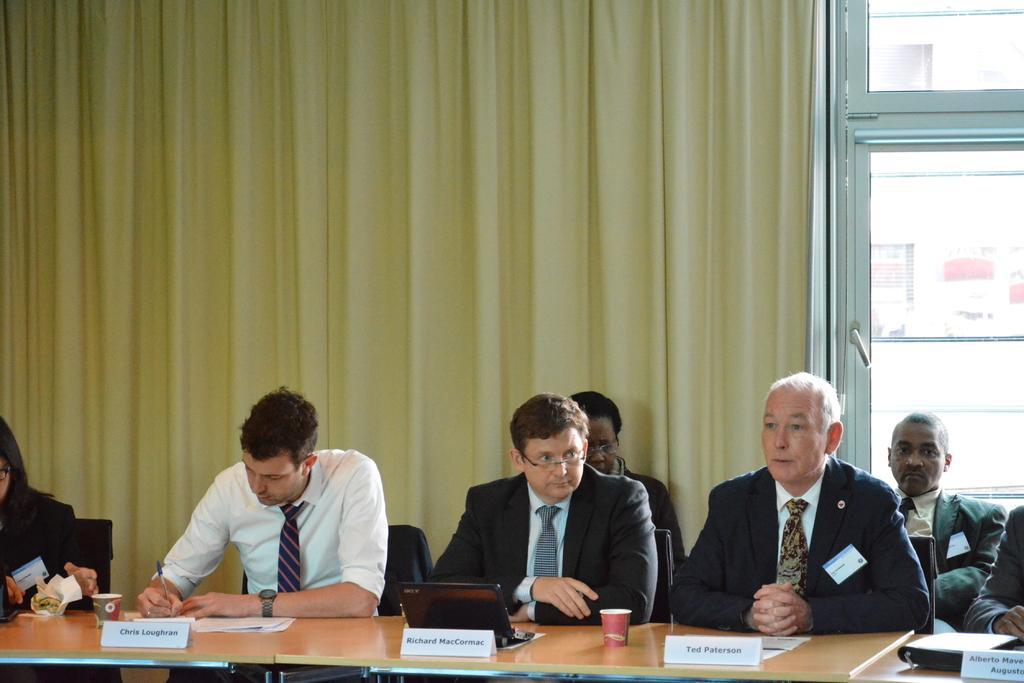In one or two sentences, can you explain what this image depicts? This picture is clicked in a conference hall. Here, we see seven people sitting on chair. In front of them, we see a table on which laptop, glass, paper and name boards are placed on this table. Behind them, we see a yellow curtain and beside that, we see window from which we see white color building. 